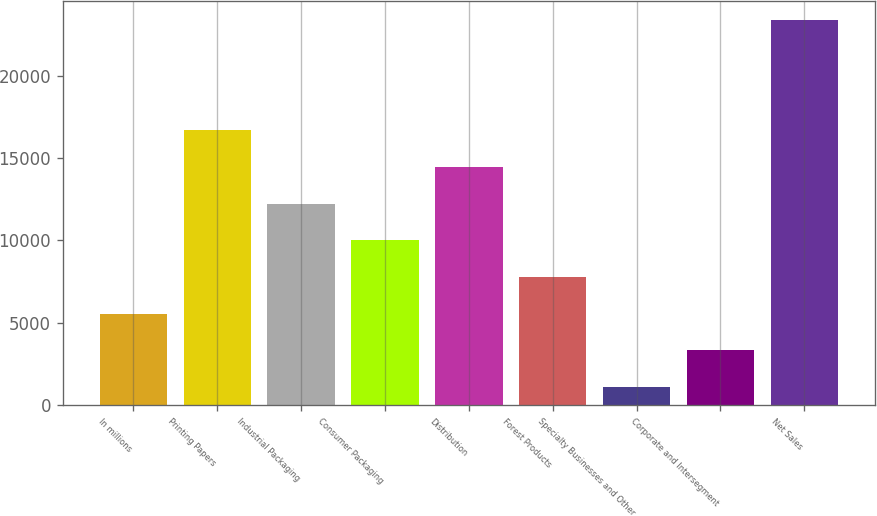Convert chart to OTSL. <chart><loc_0><loc_0><loc_500><loc_500><bar_chart><fcel>In millions<fcel>Printing Papers<fcel>Industrial Packaging<fcel>Consumer Packaging<fcel>Distribution<fcel>Forest Products<fcel>Specialty Businesses and Other<fcel>Corporate and Intersegment<fcel>Net Sales<nl><fcel>5567.8<fcel>16687.3<fcel>12239.5<fcel>10015.6<fcel>14463.4<fcel>7791.7<fcel>1120<fcel>3343.9<fcel>23359<nl></chart> 